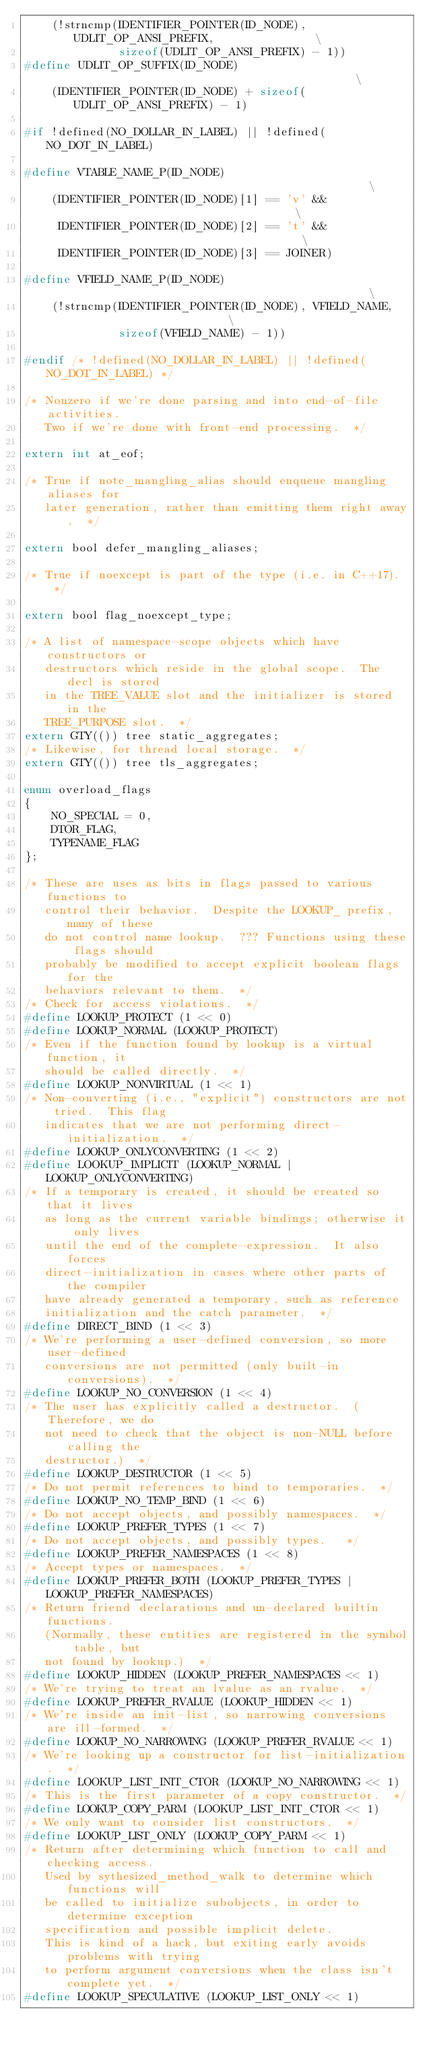Convert code to text. <code><loc_0><loc_0><loc_500><loc_500><_C_>    (!strncmp(IDENTIFIER_POINTER(ID_NODE), UDLIT_OP_ANSI_PREFIX,               \
              sizeof(UDLIT_OP_ANSI_PREFIX) - 1))
#define UDLIT_OP_SUFFIX(ID_NODE)                                               \
    (IDENTIFIER_POINTER(ID_NODE) + sizeof(UDLIT_OP_ANSI_PREFIX) - 1)

#if !defined(NO_DOLLAR_IN_LABEL) || !defined(NO_DOT_IN_LABEL)

#define VTABLE_NAME_P(ID_NODE)                                                 \
    (IDENTIFIER_POINTER(ID_NODE)[1] == 'v' &&                                  \
     IDENTIFIER_POINTER(ID_NODE)[2] == 't' &&                                  \
     IDENTIFIER_POINTER(ID_NODE)[3] == JOINER)

#define VFIELD_NAME_P(ID_NODE)                                                 \
    (!strncmp(IDENTIFIER_POINTER(ID_NODE), VFIELD_NAME,                        \
              sizeof(VFIELD_NAME) - 1))

#endif /* !defined(NO_DOLLAR_IN_LABEL) || !defined(NO_DOT_IN_LABEL) */

/* Nonzero if we're done parsing and into end-of-file activities.
   Two if we're done with front-end processing.  */

extern int at_eof;

/* True if note_mangling_alias should enqueue mangling aliases for
   later generation, rather than emitting them right away.  */

extern bool defer_mangling_aliases;

/* True if noexcept is part of the type (i.e. in C++17).  */

extern bool flag_noexcept_type;

/* A list of namespace-scope objects which have constructors or
   destructors which reside in the global scope.  The decl is stored
   in the TREE_VALUE slot and the initializer is stored in the
   TREE_PURPOSE slot.  */
extern GTY(()) tree static_aggregates;
/* Likewise, for thread local storage.  */
extern GTY(()) tree tls_aggregates;

enum overload_flags
{
    NO_SPECIAL = 0,
    DTOR_FLAG,
    TYPENAME_FLAG
};

/* These are uses as bits in flags passed to various functions to
   control their behavior.  Despite the LOOKUP_ prefix, many of these
   do not control name lookup.  ??? Functions using these flags should
   probably be modified to accept explicit boolean flags for the
   behaviors relevant to them.  */
/* Check for access violations.  */
#define LOOKUP_PROTECT (1 << 0)
#define LOOKUP_NORMAL (LOOKUP_PROTECT)
/* Even if the function found by lookup is a virtual function, it
   should be called directly.  */
#define LOOKUP_NONVIRTUAL (1 << 1)
/* Non-converting (i.e., "explicit") constructors are not tried.  This flag
   indicates that we are not performing direct-initialization.  */
#define LOOKUP_ONLYCONVERTING (1 << 2)
#define LOOKUP_IMPLICIT (LOOKUP_NORMAL | LOOKUP_ONLYCONVERTING)
/* If a temporary is created, it should be created so that it lives
   as long as the current variable bindings; otherwise it only lives
   until the end of the complete-expression.  It also forces
   direct-initialization in cases where other parts of the compiler
   have already generated a temporary, such as reference
   initialization and the catch parameter.  */
#define DIRECT_BIND (1 << 3)
/* We're performing a user-defined conversion, so more user-defined
   conversions are not permitted (only built-in conversions).  */
#define LOOKUP_NO_CONVERSION (1 << 4)
/* The user has explicitly called a destructor.  (Therefore, we do
   not need to check that the object is non-NULL before calling the
   destructor.)  */
#define LOOKUP_DESTRUCTOR (1 << 5)
/* Do not permit references to bind to temporaries.  */
#define LOOKUP_NO_TEMP_BIND (1 << 6)
/* Do not accept objects, and possibly namespaces.  */
#define LOOKUP_PREFER_TYPES (1 << 7)
/* Do not accept objects, and possibly types.   */
#define LOOKUP_PREFER_NAMESPACES (1 << 8)
/* Accept types or namespaces.  */
#define LOOKUP_PREFER_BOTH (LOOKUP_PREFER_TYPES | LOOKUP_PREFER_NAMESPACES)
/* Return friend declarations and un-declared builtin functions.
   (Normally, these entities are registered in the symbol table, but
   not found by lookup.)  */
#define LOOKUP_HIDDEN (LOOKUP_PREFER_NAMESPACES << 1)
/* We're trying to treat an lvalue as an rvalue.  */
#define LOOKUP_PREFER_RVALUE (LOOKUP_HIDDEN << 1)
/* We're inside an init-list, so narrowing conversions are ill-formed.  */
#define LOOKUP_NO_NARROWING (LOOKUP_PREFER_RVALUE << 1)
/* We're looking up a constructor for list-initialization.  */
#define LOOKUP_LIST_INIT_CTOR (LOOKUP_NO_NARROWING << 1)
/* This is the first parameter of a copy constructor.  */
#define LOOKUP_COPY_PARM (LOOKUP_LIST_INIT_CTOR << 1)
/* We only want to consider list constructors.  */
#define LOOKUP_LIST_ONLY (LOOKUP_COPY_PARM << 1)
/* Return after determining which function to call and checking access.
   Used by sythesized_method_walk to determine which functions will
   be called to initialize subobjects, in order to determine exception
   specification and possible implicit delete.
   This is kind of a hack, but exiting early avoids problems with trying
   to perform argument conversions when the class isn't complete yet.  */
#define LOOKUP_SPECULATIVE (LOOKUP_LIST_ONLY << 1)</code> 